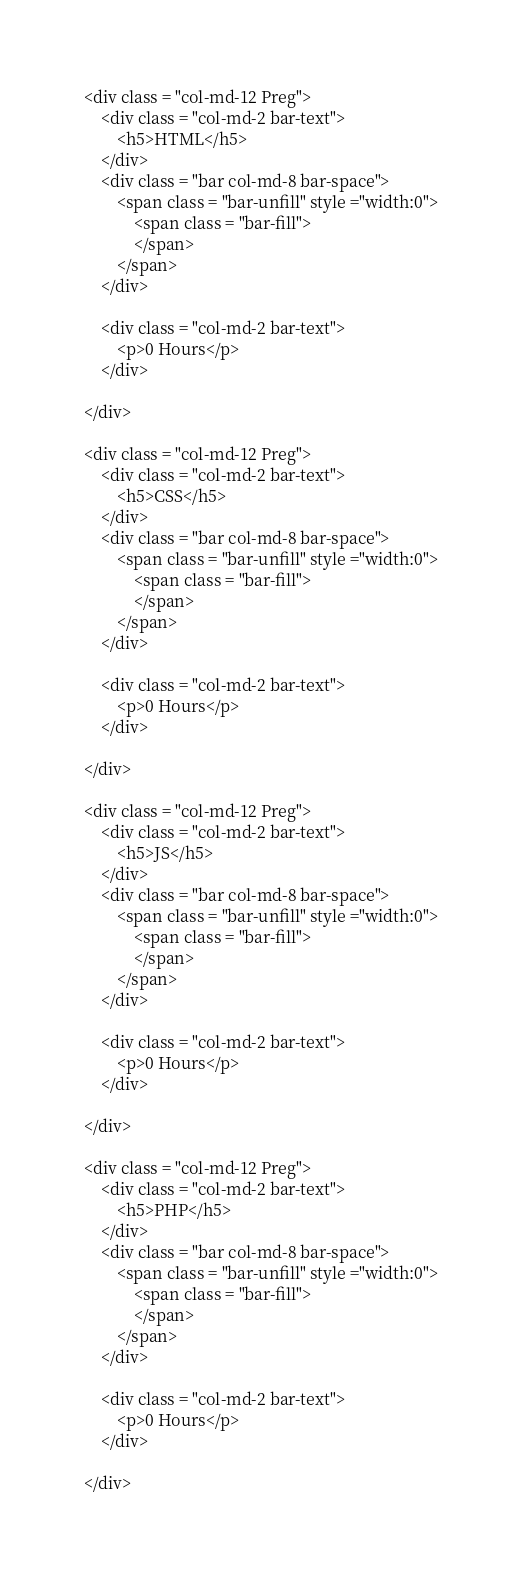Convert code to text. <code><loc_0><loc_0><loc_500><loc_500><_PHP_><div class = "col-md-12 Preg">
    <div class = "col-md-2 bar-text">
        <h5>HTML</h5>
    </div>
    <div class = "bar col-md-8 bar-space">
        <span class = "bar-unfill" style ="width:0">
            <span class = "bar-fill">
            </span>
        </span>
    </div>

    <div class = "col-md-2 bar-text">
        <p>0 Hours</p>
    </div>

</div>

<div class = "col-md-12 Preg">
    <div class = "col-md-2 bar-text">
        <h5>CSS</h5>
    </div>
    <div class = "bar col-md-8 bar-space">
        <span class = "bar-unfill" style ="width:0">
            <span class = "bar-fill">
            </span>
        </span>
    </div>

    <div class = "col-md-2 bar-text">
        <p>0 Hours</p>
    </div>

</div>

<div class = "col-md-12 Preg">
    <div class = "col-md-2 bar-text">
        <h5>JS</h5>
    </div>
    <div class = "bar col-md-8 bar-space">
        <span class = "bar-unfill" style ="width:0">
            <span class = "bar-fill">
            </span>
        </span>
    </div>

    <div class = "col-md-2 bar-text">
        <p>0 Hours</p>
    </div>

</div>

<div class = "col-md-12 Preg">
    <div class = "col-md-2 bar-text">
        <h5>PHP</h5>
    </div>
    <div class = "bar col-md-8 bar-space">
        <span class = "bar-unfill" style ="width:0">
            <span class = "bar-fill">
            </span>
        </span>
    </div>

    <div class = "col-md-2 bar-text">
        <p>0 Hours</p>
    </div>

</div>

</code> 